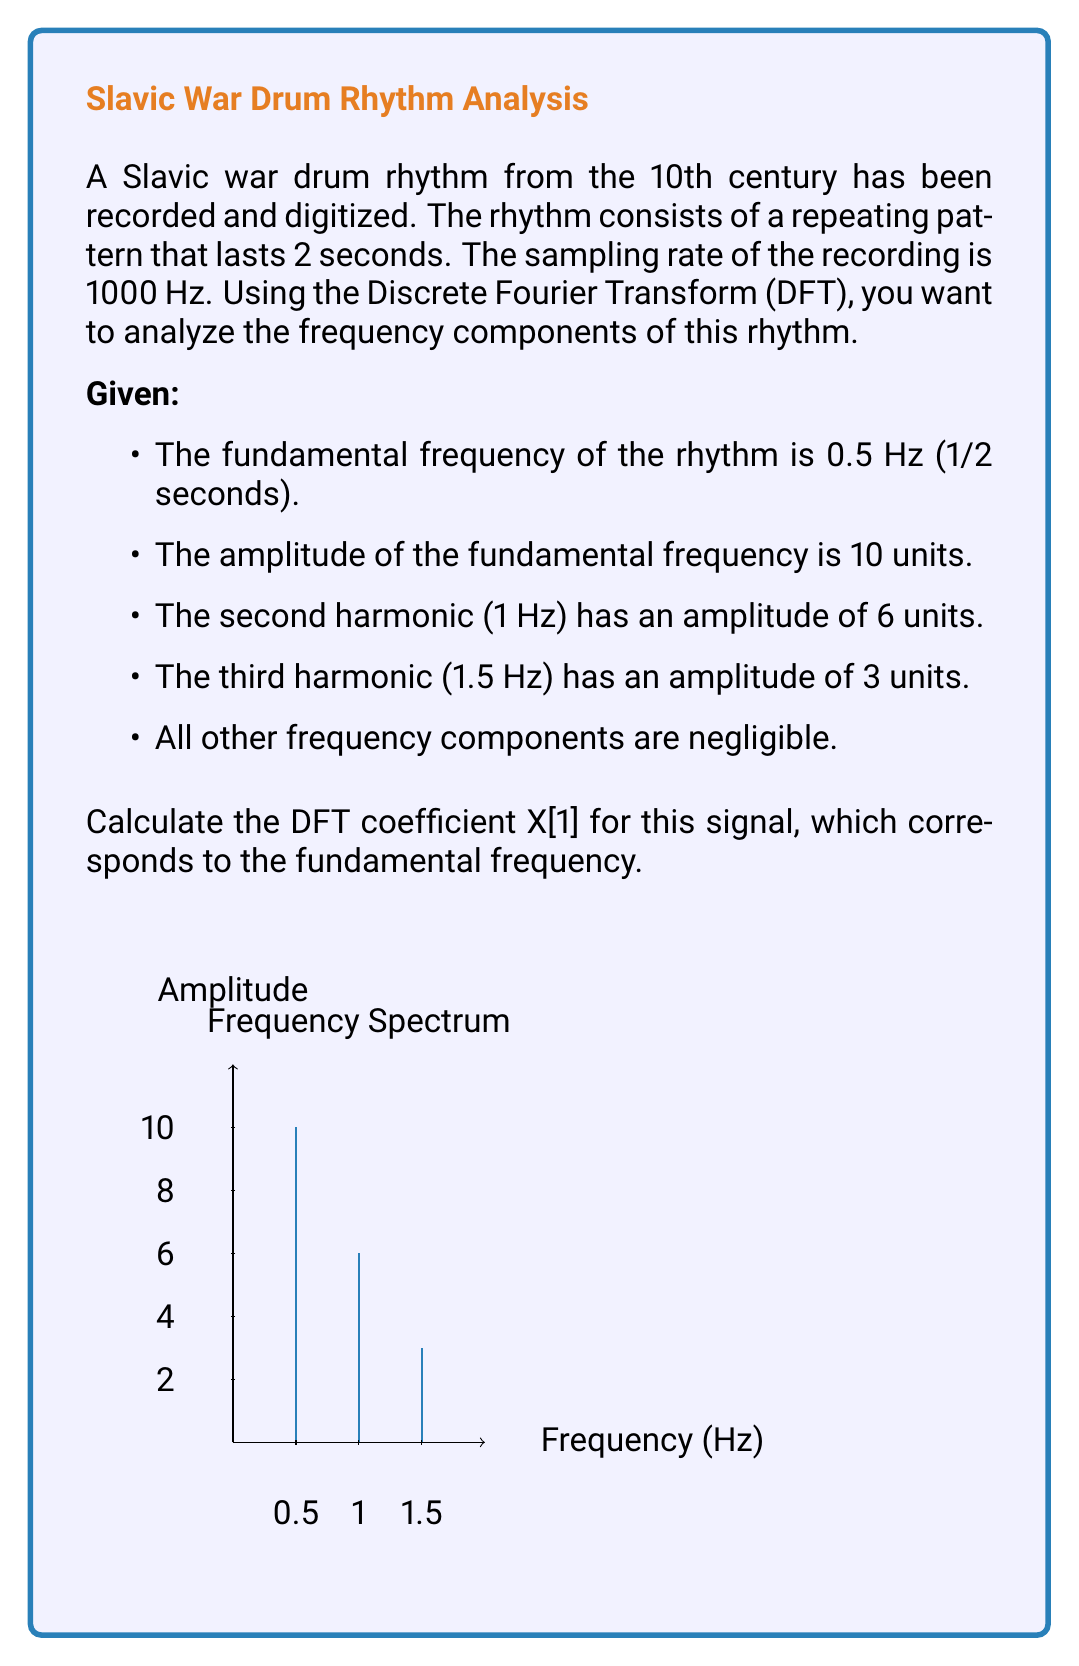Can you answer this question? Let's approach this step-by-step:

1) The DFT coefficient X[k] for a signal x[n] of length N is given by:

   $$X[k] = \sum_{n=0}^{N-1} x[n] e^{-j2\pi kn/N}$$

2) In this case, we're interested in X[1], which corresponds to the fundamental frequency of 0.5 Hz.

3) The number of samples N is:
   N = sampling rate × duration = 1000 × 2 = 2000 samples

4) The signal x[n] can be represented as a sum of cosines:

   $$x[n] = 10\cos(2\pi \cdot 0.5n/1000) + 6\cos(2\pi \cdot 1n/1000) + 3\cos(2\pi \cdot 1.5n/1000)$$

5) Substituting this into the DFT formula:

   $$X[1] = \sum_{n=0}^{1999} [10\cos(2\pi \cdot 0.5n/1000) + 6\cos(2\pi \cdot 1n/1000) + 3\cos(2\pi \cdot 1.5n/1000)] e^{-j2\pi n/2000}$$

6) This sum can be simplified using the properties of DFT. For a cosine signal $A\cos(2\pi f_0 n/f_s)$, its DFT coefficient at $k = f_0 N / f_s$ is $AN/2$.

7) In our case, for the fundamental frequency (0.5 Hz):
   $k = 0.5 \cdot 2000 / 1000 = 1$
   
   Therefore, the contribution of the fundamental frequency to X[1] is:
   $10 \cdot 2000 / 2 = 10000$

8) The other harmonics don't contribute to X[1].

9) Thus, X[1] = 10000
Answer: X[1] = 10000 